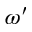<formula> <loc_0><loc_0><loc_500><loc_500>\omega ^ { \prime }</formula> 